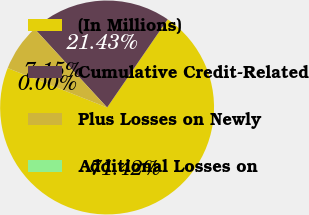Convert chart to OTSL. <chart><loc_0><loc_0><loc_500><loc_500><pie_chart><fcel>(In Millions)<fcel>Cumulative Credit-Related<fcel>Plus Losses on Newly<fcel>Additional Losses on<nl><fcel>71.42%<fcel>21.43%<fcel>7.15%<fcel>0.0%<nl></chart> 